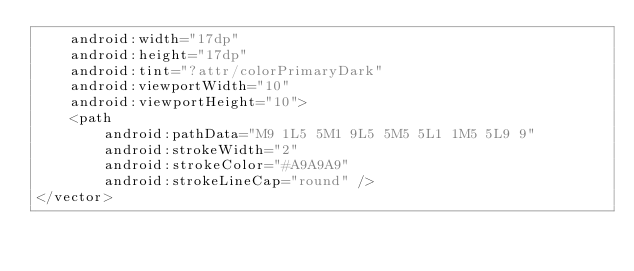Convert code to text. <code><loc_0><loc_0><loc_500><loc_500><_XML_>    android:width="17dp"
    android:height="17dp"
    android:tint="?attr/colorPrimaryDark"
    android:viewportWidth="10"
    android:viewportHeight="10">
    <path
        android:pathData="M9 1L5 5M1 9L5 5M5 5L1 1M5 5L9 9"
        android:strokeWidth="2"
        android:strokeColor="#A9A9A9"
        android:strokeLineCap="round" />
</vector>
</code> 